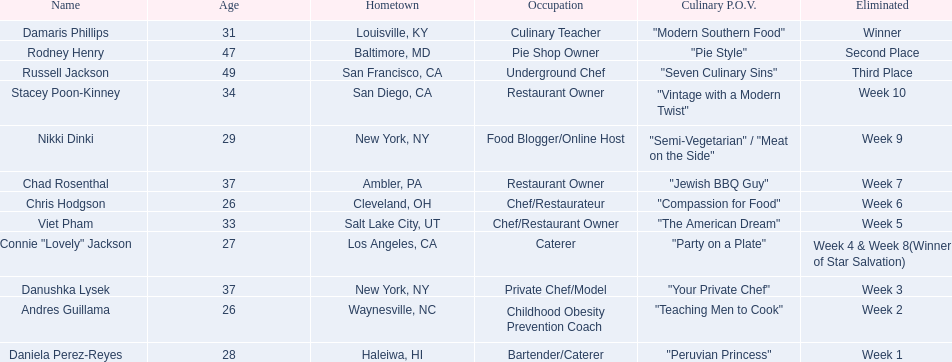Who are all of the contestants? Damaris Phillips, Rodney Henry, Russell Jackson, Stacey Poon-Kinney, Nikki Dinki, Chad Rosenthal, Chris Hodgson, Viet Pham, Connie "Lovely" Jackson, Danushka Lysek, Andres Guillama, Daniela Perez-Reyes. What is each player's culinary point of view? "Modern Southern Food", "Pie Style", "Seven Culinary Sins", "Vintage with a Modern Twist", "Semi-Vegetarian" / "Meat on the Side", "Jewish BBQ Guy", "Compassion for Food", "The American Dream", "Party on a Plate", "Your Private Chef", "Teaching Men to Cook", "Peruvian Princess". And which player's point of view is the longest? Nikki Dinki. 